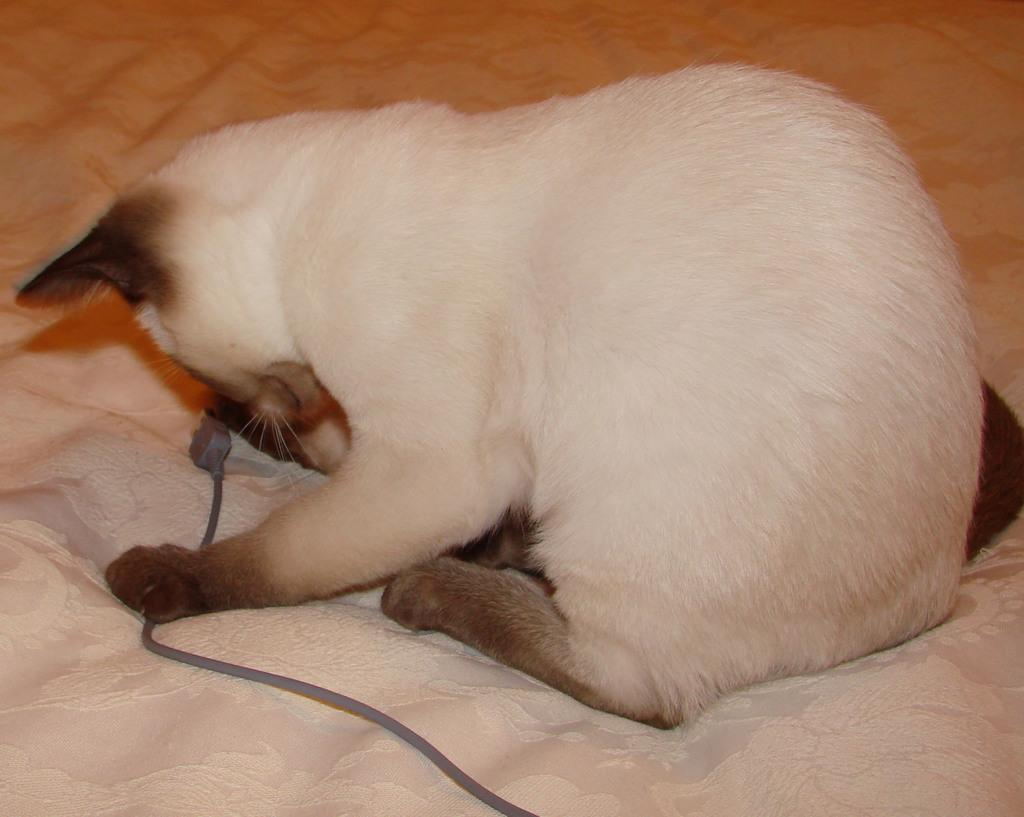What type of animal is in the image? The type of animal cannot be determined from the provided facts. Where is the animal located in the image? The animal is on a bed in the image. What else is on the bed in the image? There is a cable on the bed in the image. Can you hear the animal cry in the image? There is no sound or indication of any noise in the image, so it cannot be determined if the animal is crying. 